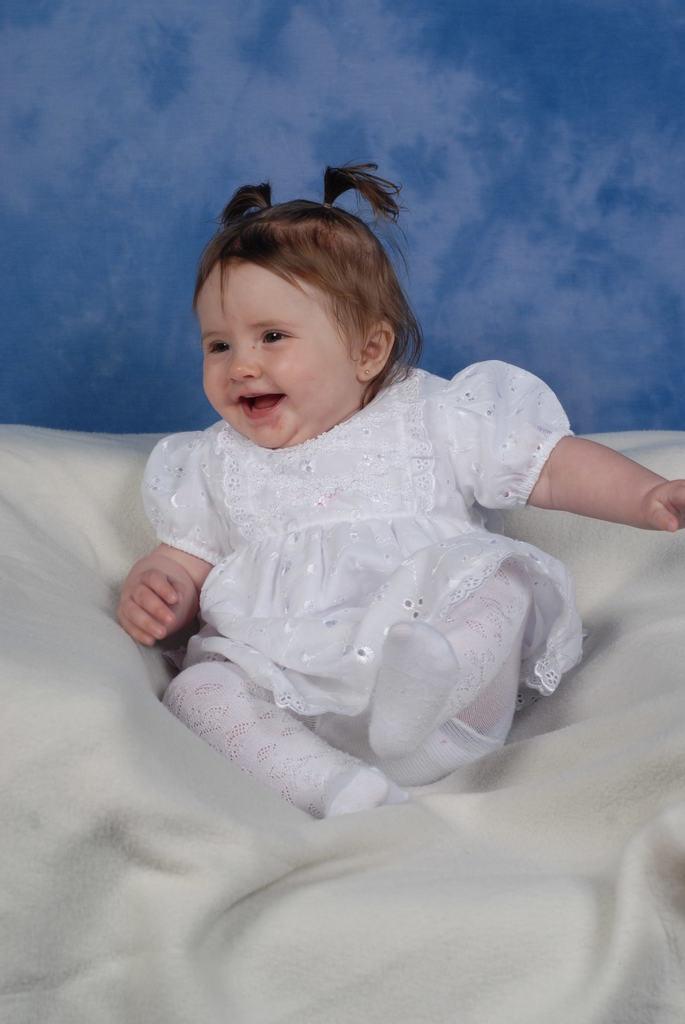How would you summarize this image in a sentence or two? As we can see in the image there is a girl sitting on white color bed sheet. Behind her there is a blue color wall. 